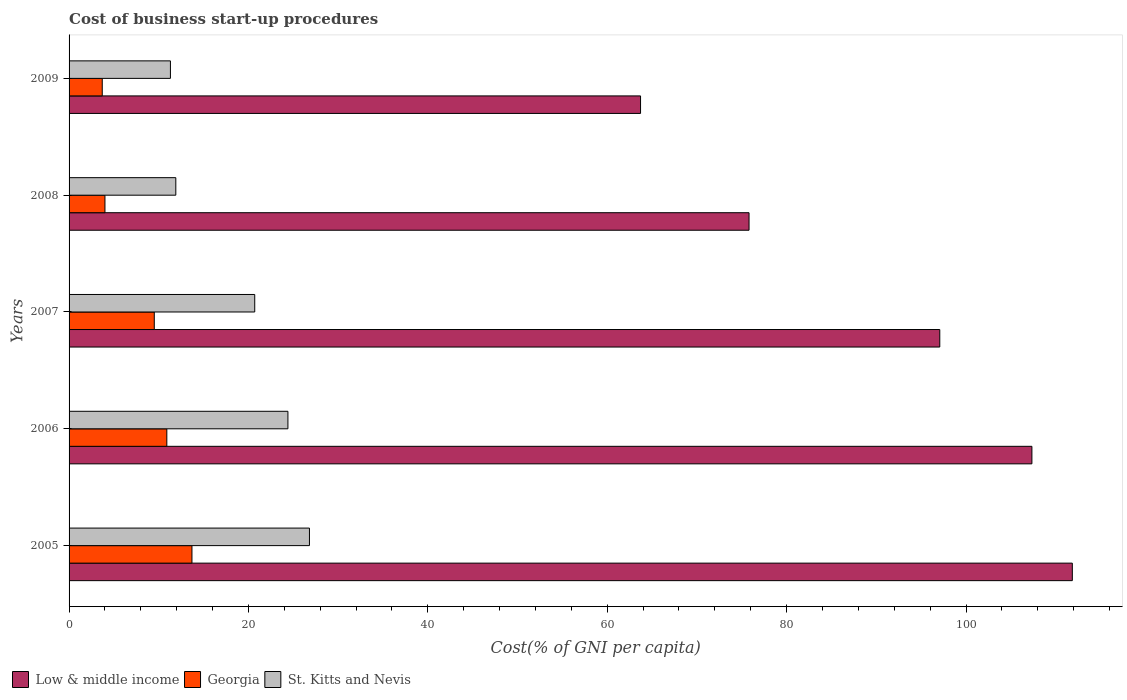Are the number of bars per tick equal to the number of legend labels?
Provide a short and direct response. Yes. Are the number of bars on each tick of the Y-axis equal?
Your answer should be compact. Yes. How many bars are there on the 4th tick from the top?
Provide a short and direct response. 3. How many bars are there on the 4th tick from the bottom?
Your answer should be compact. 3. Across all years, what is the maximum cost of business start-up procedures in Low & middle income?
Give a very brief answer. 111.86. Across all years, what is the minimum cost of business start-up procedures in Georgia?
Offer a terse response. 3.7. In which year was the cost of business start-up procedures in Georgia maximum?
Your answer should be very brief. 2005. In which year was the cost of business start-up procedures in Georgia minimum?
Make the answer very short. 2009. What is the total cost of business start-up procedures in Georgia in the graph?
Make the answer very short. 41.8. What is the difference between the cost of business start-up procedures in Georgia in 2009 and the cost of business start-up procedures in St. Kitts and Nevis in 2007?
Provide a short and direct response. -17. What is the average cost of business start-up procedures in St. Kitts and Nevis per year?
Provide a succinct answer. 19.02. In the year 2008, what is the difference between the cost of business start-up procedures in St. Kitts and Nevis and cost of business start-up procedures in Georgia?
Keep it short and to the point. 7.9. What is the ratio of the cost of business start-up procedures in Georgia in 2006 to that in 2007?
Keep it short and to the point. 1.15. What is the difference between the highest and the second highest cost of business start-up procedures in Georgia?
Your response must be concise. 2.8. In how many years, is the cost of business start-up procedures in Georgia greater than the average cost of business start-up procedures in Georgia taken over all years?
Your answer should be compact. 3. What does the 1st bar from the top in 2009 represents?
Give a very brief answer. St. Kitts and Nevis. What does the 1st bar from the bottom in 2005 represents?
Provide a succinct answer. Low & middle income. Is it the case that in every year, the sum of the cost of business start-up procedures in St. Kitts and Nevis and cost of business start-up procedures in Georgia is greater than the cost of business start-up procedures in Low & middle income?
Give a very brief answer. No. How many bars are there?
Provide a succinct answer. 15. What is the difference between two consecutive major ticks on the X-axis?
Keep it short and to the point. 20. Does the graph contain grids?
Keep it short and to the point. No. How many legend labels are there?
Your answer should be compact. 3. What is the title of the graph?
Provide a succinct answer. Cost of business start-up procedures. Does "Serbia" appear as one of the legend labels in the graph?
Offer a terse response. No. What is the label or title of the X-axis?
Your answer should be very brief. Cost(% of GNI per capita). What is the label or title of the Y-axis?
Your answer should be very brief. Years. What is the Cost(% of GNI per capita) in Low & middle income in 2005?
Offer a very short reply. 111.86. What is the Cost(% of GNI per capita) of Georgia in 2005?
Your answer should be compact. 13.7. What is the Cost(% of GNI per capita) of St. Kitts and Nevis in 2005?
Your answer should be very brief. 26.8. What is the Cost(% of GNI per capita) of Low & middle income in 2006?
Your answer should be compact. 107.35. What is the Cost(% of GNI per capita) of Georgia in 2006?
Provide a succinct answer. 10.9. What is the Cost(% of GNI per capita) in St. Kitts and Nevis in 2006?
Offer a terse response. 24.4. What is the Cost(% of GNI per capita) in Low & middle income in 2007?
Your answer should be compact. 97.08. What is the Cost(% of GNI per capita) in Georgia in 2007?
Offer a very short reply. 9.5. What is the Cost(% of GNI per capita) in St. Kitts and Nevis in 2007?
Your response must be concise. 20.7. What is the Cost(% of GNI per capita) of Low & middle income in 2008?
Your answer should be compact. 75.81. What is the Cost(% of GNI per capita) of Georgia in 2008?
Ensure brevity in your answer.  4. What is the Cost(% of GNI per capita) of Low & middle income in 2009?
Your response must be concise. 63.72. What is the Cost(% of GNI per capita) of Georgia in 2009?
Keep it short and to the point. 3.7. Across all years, what is the maximum Cost(% of GNI per capita) in Low & middle income?
Provide a short and direct response. 111.86. Across all years, what is the maximum Cost(% of GNI per capita) in St. Kitts and Nevis?
Your response must be concise. 26.8. Across all years, what is the minimum Cost(% of GNI per capita) in Low & middle income?
Provide a succinct answer. 63.72. Across all years, what is the minimum Cost(% of GNI per capita) of Georgia?
Your answer should be very brief. 3.7. What is the total Cost(% of GNI per capita) in Low & middle income in the graph?
Provide a short and direct response. 455.81. What is the total Cost(% of GNI per capita) of Georgia in the graph?
Your response must be concise. 41.8. What is the total Cost(% of GNI per capita) in St. Kitts and Nevis in the graph?
Provide a short and direct response. 95.1. What is the difference between the Cost(% of GNI per capita) of Low & middle income in 2005 and that in 2006?
Make the answer very short. 4.51. What is the difference between the Cost(% of GNI per capita) in Low & middle income in 2005 and that in 2007?
Make the answer very short. 14.78. What is the difference between the Cost(% of GNI per capita) in Georgia in 2005 and that in 2007?
Your response must be concise. 4.2. What is the difference between the Cost(% of GNI per capita) of Low & middle income in 2005 and that in 2008?
Your response must be concise. 36.04. What is the difference between the Cost(% of GNI per capita) in Georgia in 2005 and that in 2008?
Give a very brief answer. 9.7. What is the difference between the Cost(% of GNI per capita) of Low & middle income in 2005 and that in 2009?
Give a very brief answer. 48.14. What is the difference between the Cost(% of GNI per capita) of Georgia in 2005 and that in 2009?
Ensure brevity in your answer.  10. What is the difference between the Cost(% of GNI per capita) of Low & middle income in 2006 and that in 2007?
Offer a terse response. 10.27. What is the difference between the Cost(% of GNI per capita) in Low & middle income in 2006 and that in 2008?
Offer a terse response. 31.54. What is the difference between the Cost(% of GNI per capita) in Georgia in 2006 and that in 2008?
Offer a terse response. 6.9. What is the difference between the Cost(% of GNI per capita) of St. Kitts and Nevis in 2006 and that in 2008?
Make the answer very short. 12.5. What is the difference between the Cost(% of GNI per capita) in Low & middle income in 2006 and that in 2009?
Offer a terse response. 43.63. What is the difference between the Cost(% of GNI per capita) in Georgia in 2006 and that in 2009?
Offer a terse response. 7.2. What is the difference between the Cost(% of GNI per capita) of Low & middle income in 2007 and that in 2008?
Your answer should be compact. 21.27. What is the difference between the Cost(% of GNI per capita) in Low & middle income in 2007 and that in 2009?
Ensure brevity in your answer.  33.36. What is the difference between the Cost(% of GNI per capita) in St. Kitts and Nevis in 2007 and that in 2009?
Offer a terse response. 9.4. What is the difference between the Cost(% of GNI per capita) of Low & middle income in 2008 and that in 2009?
Provide a succinct answer. 12.1. What is the difference between the Cost(% of GNI per capita) in St. Kitts and Nevis in 2008 and that in 2009?
Give a very brief answer. 0.6. What is the difference between the Cost(% of GNI per capita) in Low & middle income in 2005 and the Cost(% of GNI per capita) in Georgia in 2006?
Offer a very short reply. 100.96. What is the difference between the Cost(% of GNI per capita) of Low & middle income in 2005 and the Cost(% of GNI per capita) of St. Kitts and Nevis in 2006?
Your answer should be very brief. 87.46. What is the difference between the Cost(% of GNI per capita) of Low & middle income in 2005 and the Cost(% of GNI per capita) of Georgia in 2007?
Your response must be concise. 102.36. What is the difference between the Cost(% of GNI per capita) in Low & middle income in 2005 and the Cost(% of GNI per capita) in St. Kitts and Nevis in 2007?
Your answer should be very brief. 91.16. What is the difference between the Cost(% of GNI per capita) of Low & middle income in 2005 and the Cost(% of GNI per capita) of Georgia in 2008?
Keep it short and to the point. 107.86. What is the difference between the Cost(% of GNI per capita) of Low & middle income in 2005 and the Cost(% of GNI per capita) of St. Kitts and Nevis in 2008?
Give a very brief answer. 99.96. What is the difference between the Cost(% of GNI per capita) in Low & middle income in 2005 and the Cost(% of GNI per capita) in Georgia in 2009?
Provide a short and direct response. 108.16. What is the difference between the Cost(% of GNI per capita) of Low & middle income in 2005 and the Cost(% of GNI per capita) of St. Kitts and Nevis in 2009?
Provide a succinct answer. 100.56. What is the difference between the Cost(% of GNI per capita) in Georgia in 2005 and the Cost(% of GNI per capita) in St. Kitts and Nevis in 2009?
Offer a terse response. 2.4. What is the difference between the Cost(% of GNI per capita) in Low & middle income in 2006 and the Cost(% of GNI per capita) in Georgia in 2007?
Give a very brief answer. 97.85. What is the difference between the Cost(% of GNI per capita) of Low & middle income in 2006 and the Cost(% of GNI per capita) of St. Kitts and Nevis in 2007?
Your answer should be very brief. 86.65. What is the difference between the Cost(% of GNI per capita) of Low & middle income in 2006 and the Cost(% of GNI per capita) of Georgia in 2008?
Provide a succinct answer. 103.35. What is the difference between the Cost(% of GNI per capita) of Low & middle income in 2006 and the Cost(% of GNI per capita) of St. Kitts and Nevis in 2008?
Provide a succinct answer. 95.45. What is the difference between the Cost(% of GNI per capita) of Low & middle income in 2006 and the Cost(% of GNI per capita) of Georgia in 2009?
Your response must be concise. 103.65. What is the difference between the Cost(% of GNI per capita) of Low & middle income in 2006 and the Cost(% of GNI per capita) of St. Kitts and Nevis in 2009?
Your response must be concise. 96.05. What is the difference between the Cost(% of GNI per capita) in Georgia in 2006 and the Cost(% of GNI per capita) in St. Kitts and Nevis in 2009?
Give a very brief answer. -0.4. What is the difference between the Cost(% of GNI per capita) of Low & middle income in 2007 and the Cost(% of GNI per capita) of Georgia in 2008?
Your response must be concise. 93.08. What is the difference between the Cost(% of GNI per capita) in Low & middle income in 2007 and the Cost(% of GNI per capita) in St. Kitts and Nevis in 2008?
Your response must be concise. 85.18. What is the difference between the Cost(% of GNI per capita) in Georgia in 2007 and the Cost(% of GNI per capita) in St. Kitts and Nevis in 2008?
Provide a succinct answer. -2.4. What is the difference between the Cost(% of GNI per capita) in Low & middle income in 2007 and the Cost(% of GNI per capita) in Georgia in 2009?
Make the answer very short. 93.38. What is the difference between the Cost(% of GNI per capita) in Low & middle income in 2007 and the Cost(% of GNI per capita) in St. Kitts and Nevis in 2009?
Ensure brevity in your answer.  85.78. What is the difference between the Cost(% of GNI per capita) of Low & middle income in 2008 and the Cost(% of GNI per capita) of Georgia in 2009?
Offer a terse response. 72.11. What is the difference between the Cost(% of GNI per capita) of Low & middle income in 2008 and the Cost(% of GNI per capita) of St. Kitts and Nevis in 2009?
Provide a succinct answer. 64.51. What is the average Cost(% of GNI per capita) in Low & middle income per year?
Your response must be concise. 91.16. What is the average Cost(% of GNI per capita) in Georgia per year?
Give a very brief answer. 8.36. What is the average Cost(% of GNI per capita) of St. Kitts and Nevis per year?
Provide a succinct answer. 19.02. In the year 2005, what is the difference between the Cost(% of GNI per capita) of Low & middle income and Cost(% of GNI per capita) of Georgia?
Provide a short and direct response. 98.16. In the year 2005, what is the difference between the Cost(% of GNI per capita) of Low & middle income and Cost(% of GNI per capita) of St. Kitts and Nevis?
Provide a short and direct response. 85.06. In the year 2006, what is the difference between the Cost(% of GNI per capita) in Low & middle income and Cost(% of GNI per capita) in Georgia?
Offer a terse response. 96.45. In the year 2006, what is the difference between the Cost(% of GNI per capita) of Low & middle income and Cost(% of GNI per capita) of St. Kitts and Nevis?
Ensure brevity in your answer.  82.95. In the year 2006, what is the difference between the Cost(% of GNI per capita) in Georgia and Cost(% of GNI per capita) in St. Kitts and Nevis?
Provide a succinct answer. -13.5. In the year 2007, what is the difference between the Cost(% of GNI per capita) in Low & middle income and Cost(% of GNI per capita) in Georgia?
Provide a succinct answer. 87.58. In the year 2007, what is the difference between the Cost(% of GNI per capita) of Low & middle income and Cost(% of GNI per capita) of St. Kitts and Nevis?
Keep it short and to the point. 76.38. In the year 2008, what is the difference between the Cost(% of GNI per capita) of Low & middle income and Cost(% of GNI per capita) of Georgia?
Your answer should be very brief. 71.81. In the year 2008, what is the difference between the Cost(% of GNI per capita) in Low & middle income and Cost(% of GNI per capita) in St. Kitts and Nevis?
Provide a succinct answer. 63.91. In the year 2009, what is the difference between the Cost(% of GNI per capita) of Low & middle income and Cost(% of GNI per capita) of Georgia?
Make the answer very short. 60.02. In the year 2009, what is the difference between the Cost(% of GNI per capita) of Low & middle income and Cost(% of GNI per capita) of St. Kitts and Nevis?
Your response must be concise. 52.42. In the year 2009, what is the difference between the Cost(% of GNI per capita) in Georgia and Cost(% of GNI per capita) in St. Kitts and Nevis?
Keep it short and to the point. -7.6. What is the ratio of the Cost(% of GNI per capita) in Low & middle income in 2005 to that in 2006?
Ensure brevity in your answer.  1.04. What is the ratio of the Cost(% of GNI per capita) of Georgia in 2005 to that in 2006?
Provide a short and direct response. 1.26. What is the ratio of the Cost(% of GNI per capita) of St. Kitts and Nevis in 2005 to that in 2006?
Make the answer very short. 1.1. What is the ratio of the Cost(% of GNI per capita) in Low & middle income in 2005 to that in 2007?
Your response must be concise. 1.15. What is the ratio of the Cost(% of GNI per capita) in Georgia in 2005 to that in 2007?
Make the answer very short. 1.44. What is the ratio of the Cost(% of GNI per capita) in St. Kitts and Nevis in 2005 to that in 2007?
Offer a terse response. 1.29. What is the ratio of the Cost(% of GNI per capita) of Low & middle income in 2005 to that in 2008?
Give a very brief answer. 1.48. What is the ratio of the Cost(% of GNI per capita) of Georgia in 2005 to that in 2008?
Provide a short and direct response. 3.42. What is the ratio of the Cost(% of GNI per capita) in St. Kitts and Nevis in 2005 to that in 2008?
Your answer should be very brief. 2.25. What is the ratio of the Cost(% of GNI per capita) in Low & middle income in 2005 to that in 2009?
Offer a very short reply. 1.76. What is the ratio of the Cost(% of GNI per capita) of Georgia in 2005 to that in 2009?
Provide a succinct answer. 3.7. What is the ratio of the Cost(% of GNI per capita) in St. Kitts and Nevis in 2005 to that in 2009?
Your answer should be compact. 2.37. What is the ratio of the Cost(% of GNI per capita) of Low & middle income in 2006 to that in 2007?
Offer a very short reply. 1.11. What is the ratio of the Cost(% of GNI per capita) in Georgia in 2006 to that in 2007?
Your answer should be very brief. 1.15. What is the ratio of the Cost(% of GNI per capita) in St. Kitts and Nevis in 2006 to that in 2007?
Offer a very short reply. 1.18. What is the ratio of the Cost(% of GNI per capita) in Low & middle income in 2006 to that in 2008?
Offer a terse response. 1.42. What is the ratio of the Cost(% of GNI per capita) in Georgia in 2006 to that in 2008?
Provide a short and direct response. 2.73. What is the ratio of the Cost(% of GNI per capita) in St. Kitts and Nevis in 2006 to that in 2008?
Provide a succinct answer. 2.05. What is the ratio of the Cost(% of GNI per capita) of Low & middle income in 2006 to that in 2009?
Provide a succinct answer. 1.68. What is the ratio of the Cost(% of GNI per capita) of Georgia in 2006 to that in 2009?
Provide a short and direct response. 2.95. What is the ratio of the Cost(% of GNI per capita) in St. Kitts and Nevis in 2006 to that in 2009?
Offer a terse response. 2.16. What is the ratio of the Cost(% of GNI per capita) in Low & middle income in 2007 to that in 2008?
Ensure brevity in your answer.  1.28. What is the ratio of the Cost(% of GNI per capita) in Georgia in 2007 to that in 2008?
Provide a succinct answer. 2.38. What is the ratio of the Cost(% of GNI per capita) of St. Kitts and Nevis in 2007 to that in 2008?
Keep it short and to the point. 1.74. What is the ratio of the Cost(% of GNI per capita) of Low & middle income in 2007 to that in 2009?
Your answer should be compact. 1.52. What is the ratio of the Cost(% of GNI per capita) of Georgia in 2007 to that in 2009?
Offer a terse response. 2.57. What is the ratio of the Cost(% of GNI per capita) of St. Kitts and Nevis in 2007 to that in 2009?
Your answer should be very brief. 1.83. What is the ratio of the Cost(% of GNI per capita) in Low & middle income in 2008 to that in 2009?
Give a very brief answer. 1.19. What is the ratio of the Cost(% of GNI per capita) of Georgia in 2008 to that in 2009?
Offer a terse response. 1.08. What is the ratio of the Cost(% of GNI per capita) of St. Kitts and Nevis in 2008 to that in 2009?
Offer a very short reply. 1.05. What is the difference between the highest and the second highest Cost(% of GNI per capita) in Low & middle income?
Offer a terse response. 4.51. What is the difference between the highest and the second highest Cost(% of GNI per capita) in Georgia?
Your response must be concise. 2.8. What is the difference between the highest and the second highest Cost(% of GNI per capita) in St. Kitts and Nevis?
Make the answer very short. 2.4. What is the difference between the highest and the lowest Cost(% of GNI per capita) in Low & middle income?
Offer a very short reply. 48.14. What is the difference between the highest and the lowest Cost(% of GNI per capita) of St. Kitts and Nevis?
Your answer should be very brief. 15.5. 